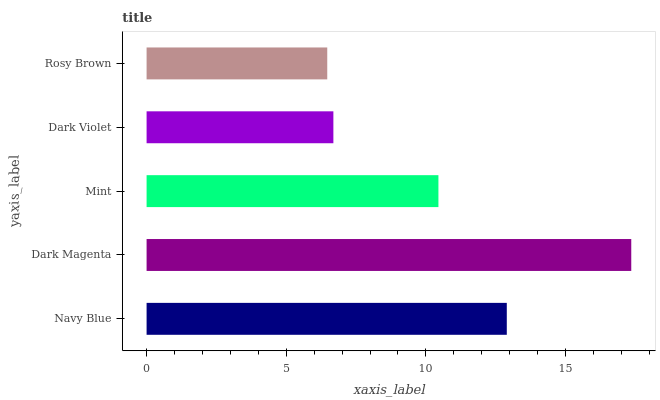Is Rosy Brown the minimum?
Answer yes or no. Yes. Is Dark Magenta the maximum?
Answer yes or no. Yes. Is Mint the minimum?
Answer yes or no. No. Is Mint the maximum?
Answer yes or no. No. Is Dark Magenta greater than Mint?
Answer yes or no. Yes. Is Mint less than Dark Magenta?
Answer yes or no. Yes. Is Mint greater than Dark Magenta?
Answer yes or no. No. Is Dark Magenta less than Mint?
Answer yes or no. No. Is Mint the high median?
Answer yes or no. Yes. Is Mint the low median?
Answer yes or no. Yes. Is Dark Magenta the high median?
Answer yes or no. No. Is Navy Blue the low median?
Answer yes or no. No. 